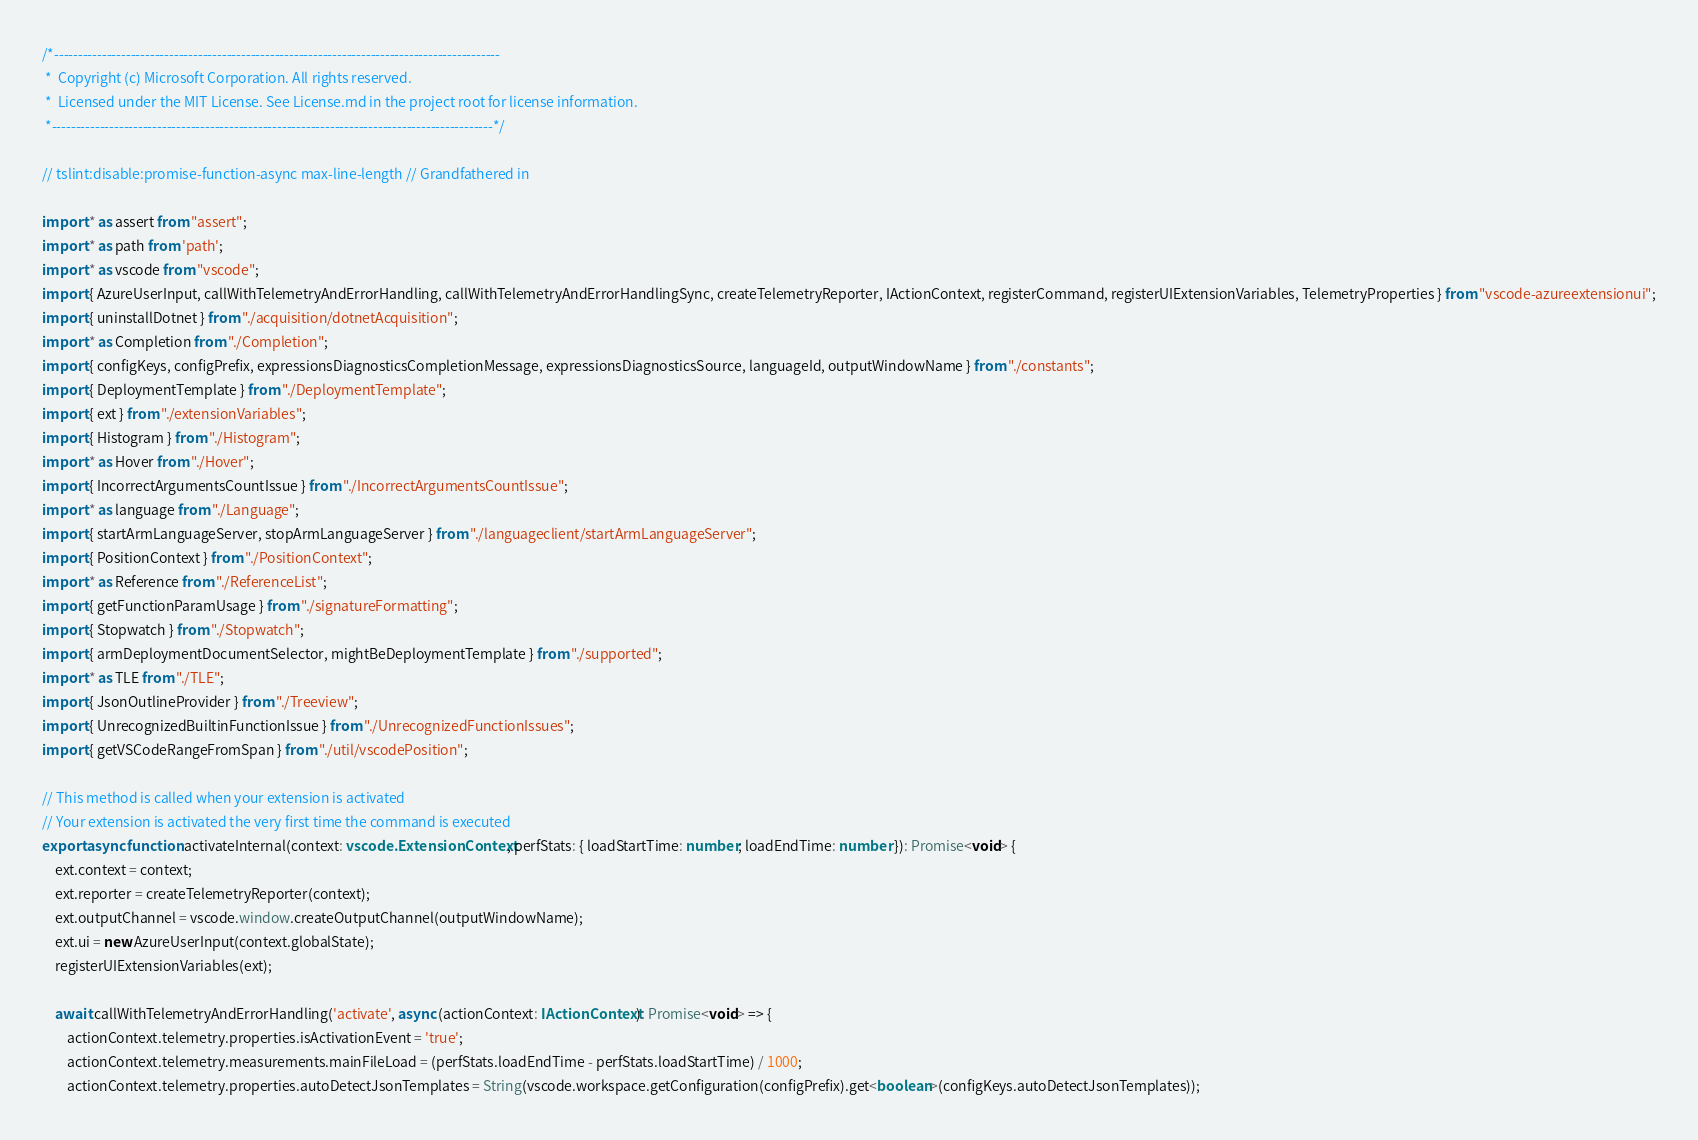<code> <loc_0><loc_0><loc_500><loc_500><_TypeScript_>/*---------------------------------------------------------------------------------------------
 *  Copyright (c) Microsoft Corporation. All rights reserved.
 *  Licensed under the MIT License. See License.md in the project root for license information.
 *--------------------------------------------------------------------------------------------*/

// tslint:disable:promise-function-async max-line-length // Grandfathered in

import * as assert from "assert";
import * as path from 'path';
import * as vscode from "vscode";
import { AzureUserInput, callWithTelemetryAndErrorHandling, callWithTelemetryAndErrorHandlingSync, createTelemetryReporter, IActionContext, registerCommand, registerUIExtensionVariables, TelemetryProperties } from "vscode-azureextensionui";
import { uninstallDotnet } from "./acquisition/dotnetAcquisition";
import * as Completion from "./Completion";
import { configKeys, configPrefix, expressionsDiagnosticsCompletionMessage, expressionsDiagnosticsSource, languageId, outputWindowName } from "./constants";
import { DeploymentTemplate } from "./DeploymentTemplate";
import { ext } from "./extensionVariables";
import { Histogram } from "./Histogram";
import * as Hover from "./Hover";
import { IncorrectArgumentsCountIssue } from "./IncorrectArgumentsCountIssue";
import * as language from "./Language";
import { startArmLanguageServer, stopArmLanguageServer } from "./languageclient/startArmLanguageServer";
import { PositionContext } from "./PositionContext";
import * as Reference from "./ReferenceList";
import { getFunctionParamUsage } from "./signatureFormatting";
import { Stopwatch } from "./Stopwatch";
import { armDeploymentDocumentSelector, mightBeDeploymentTemplate } from "./supported";
import * as TLE from "./TLE";
import { JsonOutlineProvider } from "./Treeview";
import { UnrecognizedBuiltinFunctionIssue } from "./UnrecognizedFunctionIssues";
import { getVSCodeRangeFromSpan } from "./util/vscodePosition";

// This method is called when your extension is activated
// Your extension is activated the very first time the command is executed
export async function activateInternal(context: vscode.ExtensionContext, perfStats: { loadStartTime: number; loadEndTime: number }): Promise<void> {
    ext.context = context;
    ext.reporter = createTelemetryReporter(context);
    ext.outputChannel = vscode.window.createOutputChannel(outputWindowName);
    ext.ui = new AzureUserInput(context.globalState);
    registerUIExtensionVariables(ext);

    await callWithTelemetryAndErrorHandling('activate', async (actionContext: IActionContext): Promise<void> => {
        actionContext.telemetry.properties.isActivationEvent = 'true';
        actionContext.telemetry.measurements.mainFileLoad = (perfStats.loadEndTime - perfStats.loadStartTime) / 1000;
        actionContext.telemetry.properties.autoDetectJsonTemplates = String(vscode.workspace.getConfiguration(configPrefix).get<boolean>(configKeys.autoDetectJsonTemplates));
</code> 